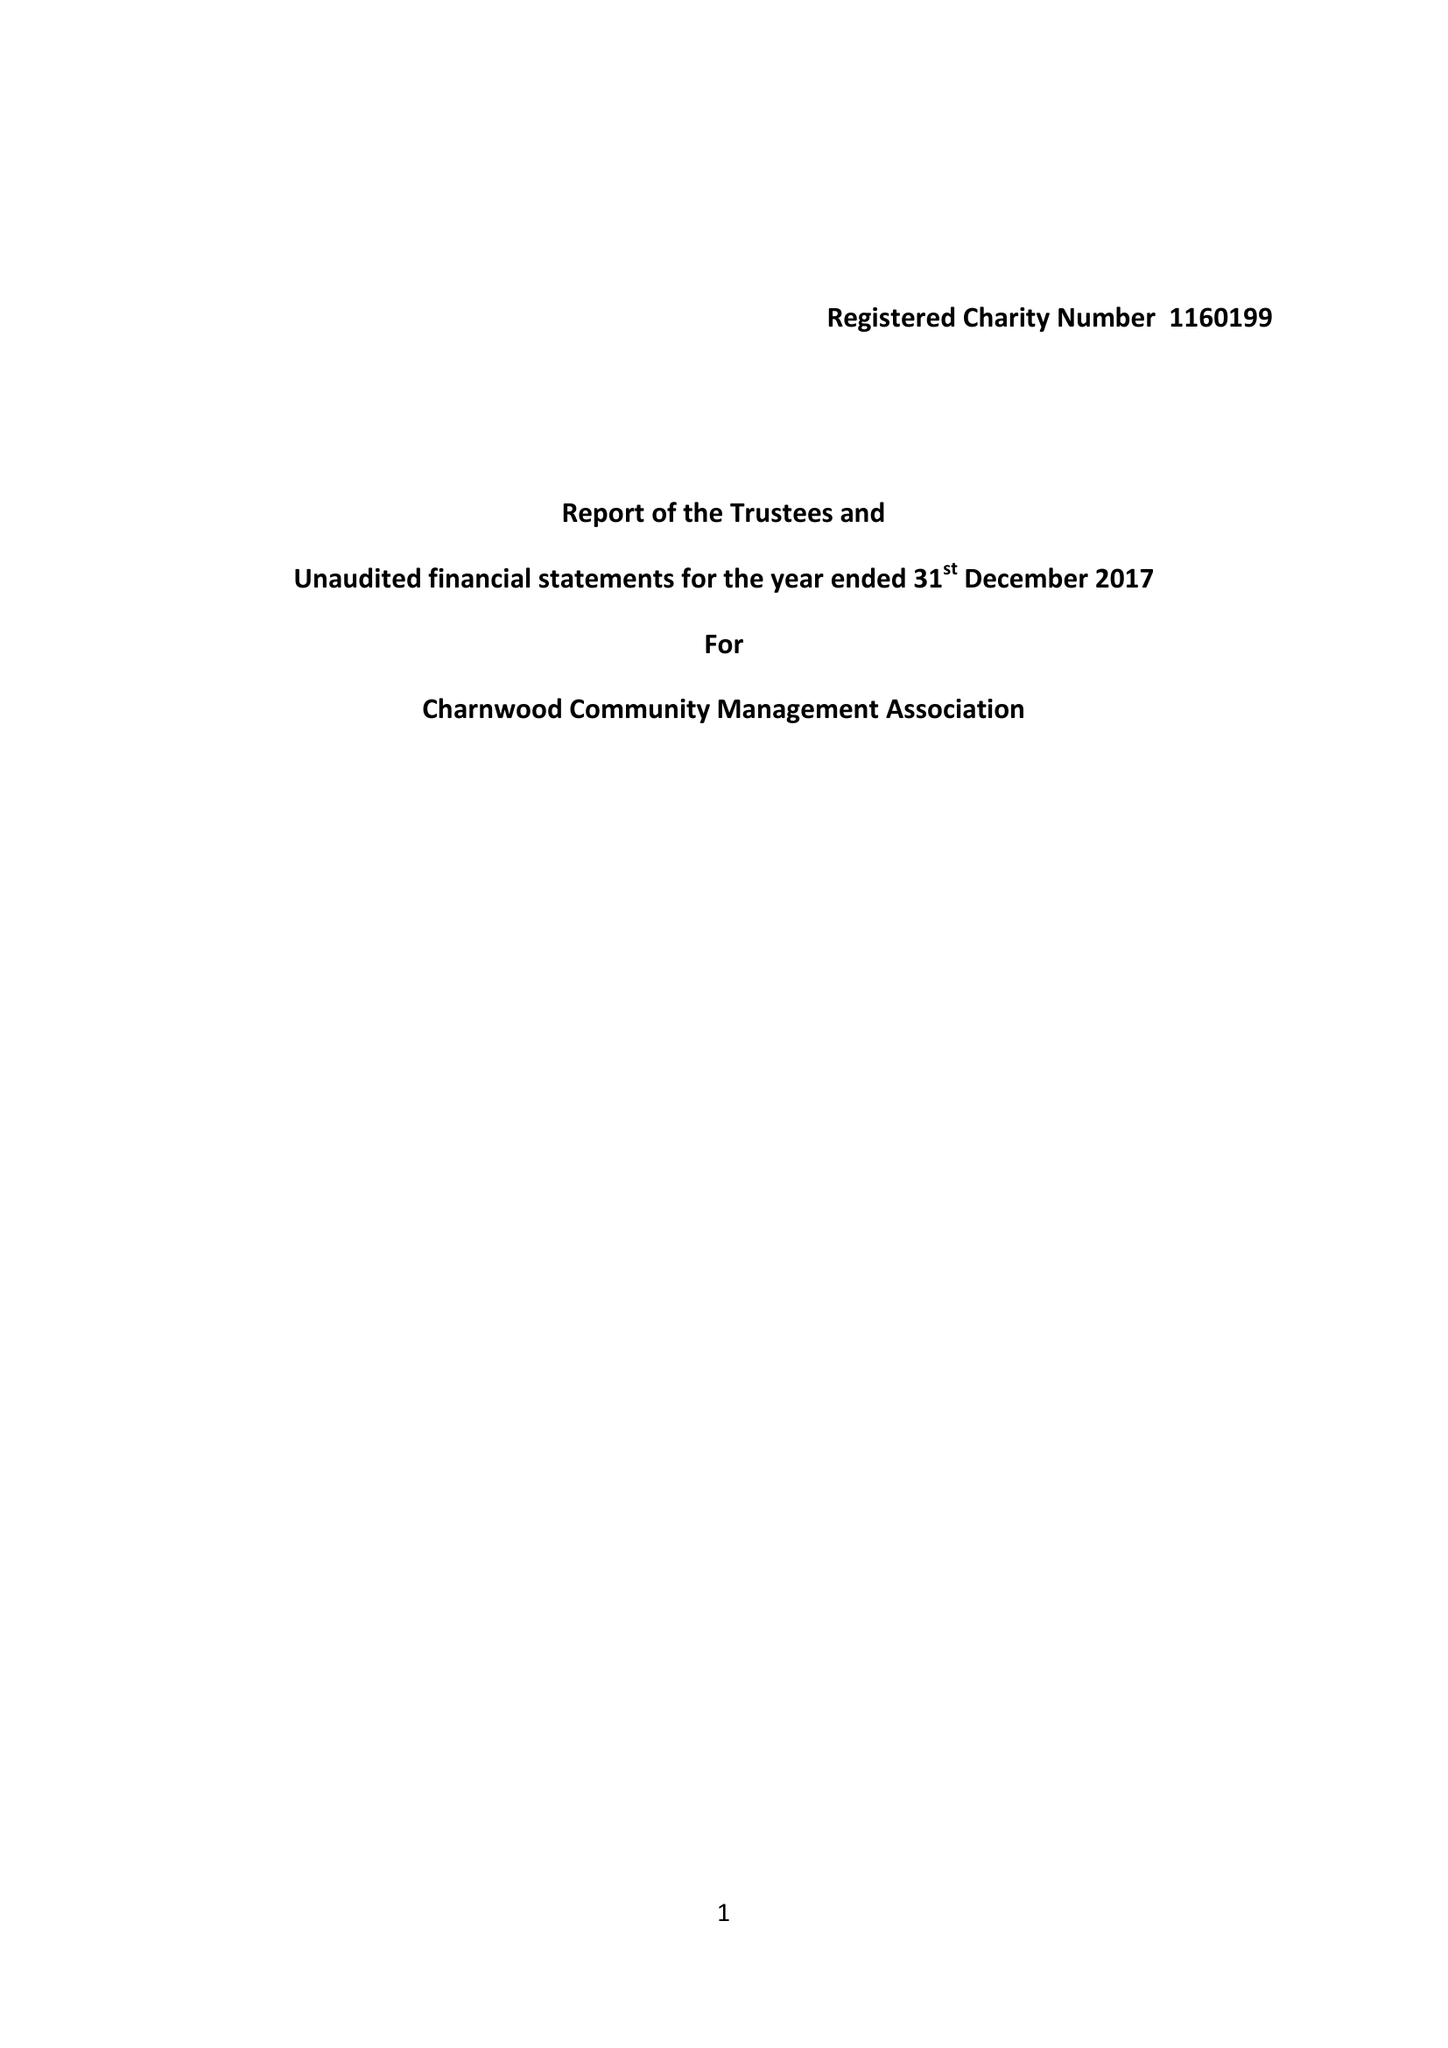What is the value for the charity_name?
Answer the question using a single word or phrase. Charnwood Community Management Association 